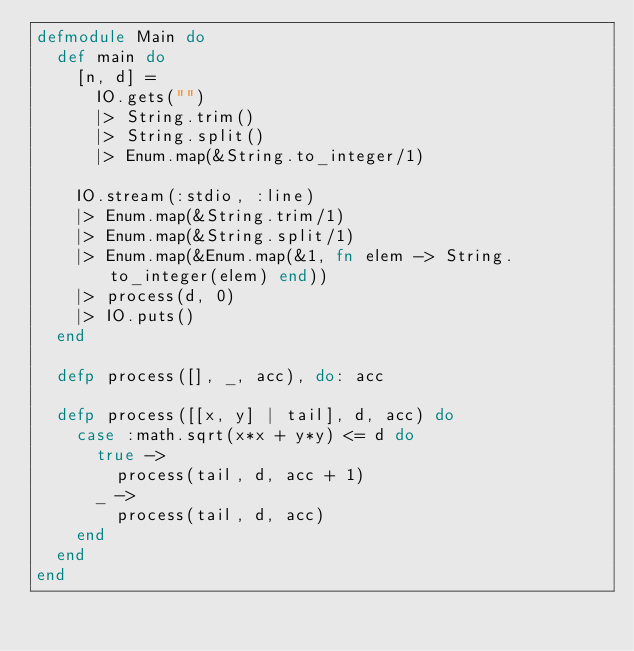Convert code to text. <code><loc_0><loc_0><loc_500><loc_500><_Elixir_>defmodule Main do
  def main do
    [n, d] = 
      IO.gets("")
      |> String.trim()
      |> String.split()
      |> Enum.map(&String.to_integer/1)
    
    IO.stream(:stdio, :line)
    |> Enum.map(&String.trim/1)
    |> Enum.map(&String.split/1)
    |> Enum.map(&Enum.map(&1, fn elem -> String.to_integer(elem) end))
    |> process(d, 0)
    |> IO.puts()
  end
  
  defp process([], _, acc), do: acc
  
  defp process([[x, y] | tail], d, acc) do
    case :math.sqrt(x*x + y*y) <= d do
      true ->
        process(tail, d, acc + 1)
      _ ->
        process(tail, d, acc)
    end
  end
end</code> 